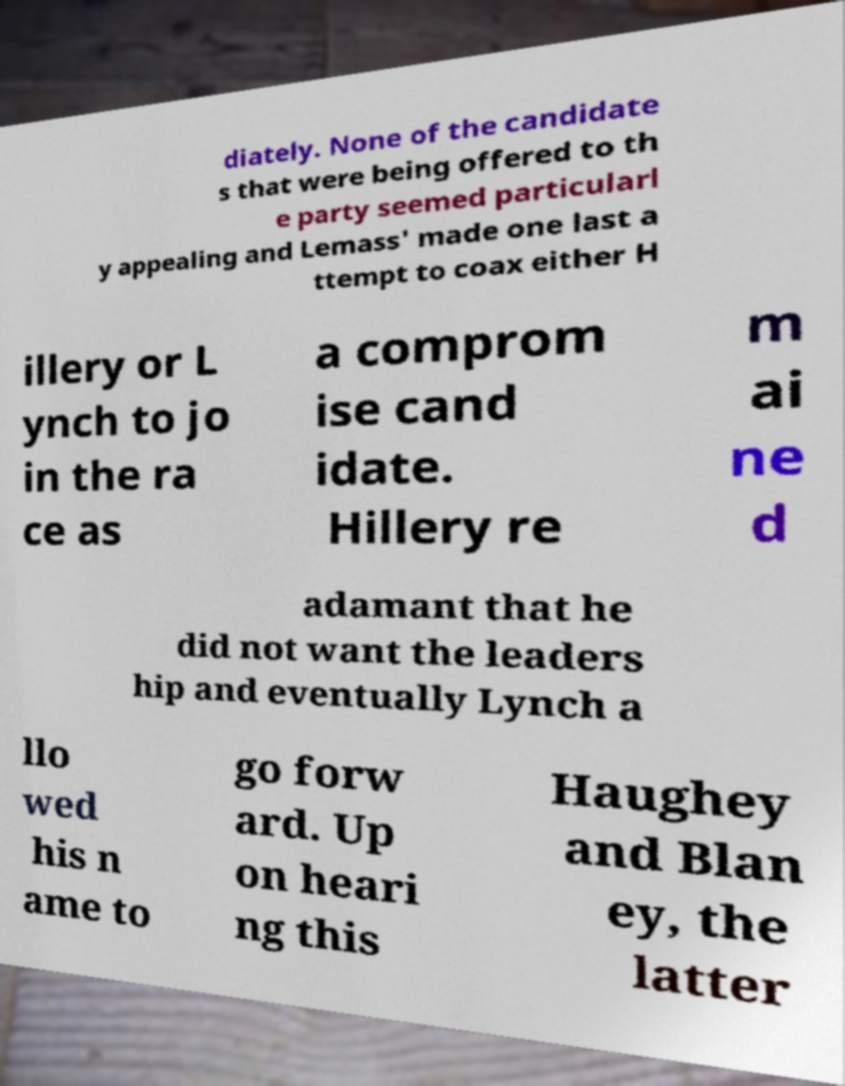There's text embedded in this image that I need extracted. Can you transcribe it verbatim? diately. None of the candidate s that were being offered to th e party seemed particularl y appealing and Lemass' made one last a ttempt to coax either H illery or L ynch to jo in the ra ce as a comprom ise cand idate. Hillery re m ai ne d adamant that he did not want the leaders hip and eventually Lynch a llo wed his n ame to go forw ard. Up on heari ng this Haughey and Blan ey, the latter 